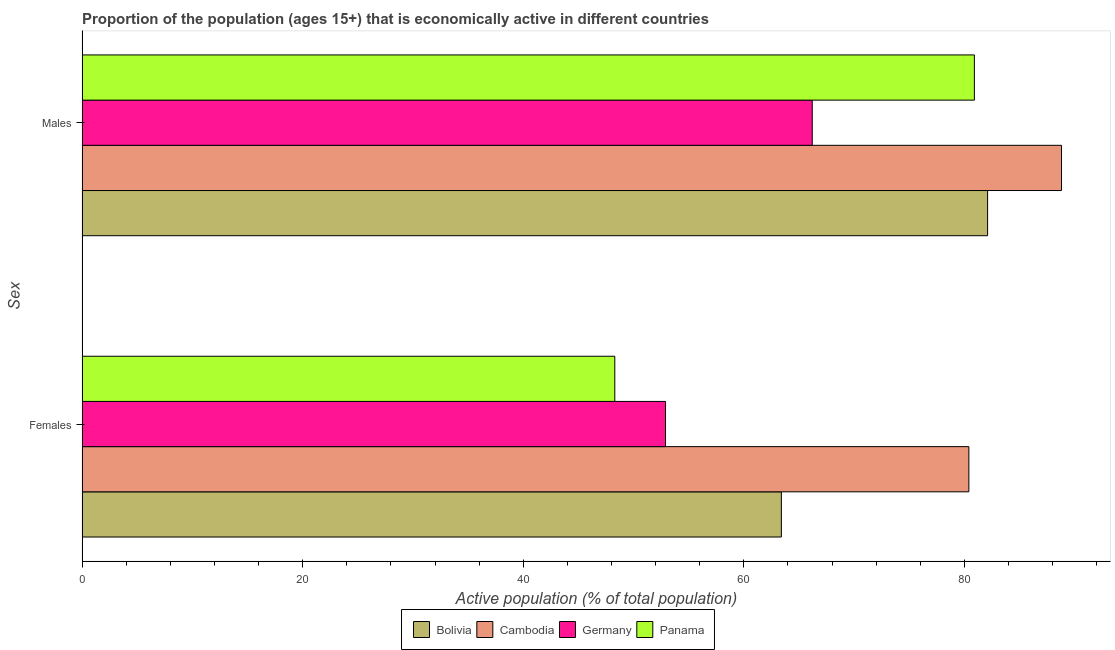How many different coloured bars are there?
Offer a very short reply. 4. How many groups of bars are there?
Your answer should be very brief. 2. How many bars are there on the 1st tick from the top?
Your answer should be compact. 4. How many bars are there on the 1st tick from the bottom?
Provide a short and direct response. 4. What is the label of the 2nd group of bars from the top?
Offer a terse response. Females. What is the percentage of economically active female population in Bolivia?
Give a very brief answer. 63.4. Across all countries, what is the maximum percentage of economically active male population?
Offer a very short reply. 88.8. Across all countries, what is the minimum percentage of economically active female population?
Provide a short and direct response. 48.3. In which country was the percentage of economically active female population maximum?
Make the answer very short. Cambodia. In which country was the percentage of economically active male population minimum?
Provide a succinct answer. Germany. What is the total percentage of economically active female population in the graph?
Your response must be concise. 245. What is the difference between the percentage of economically active male population in Cambodia and that in Panama?
Provide a succinct answer. 7.9. What is the difference between the percentage of economically active male population in Cambodia and the percentage of economically active female population in Bolivia?
Your response must be concise. 25.4. What is the average percentage of economically active female population per country?
Provide a succinct answer. 61.25. What is the difference between the percentage of economically active male population and percentage of economically active female population in Cambodia?
Give a very brief answer. 8.4. What is the ratio of the percentage of economically active female population in Panama to that in Bolivia?
Give a very brief answer. 0.76. In how many countries, is the percentage of economically active male population greater than the average percentage of economically active male population taken over all countries?
Provide a short and direct response. 3. What does the 1st bar from the top in Females represents?
Your response must be concise. Panama. What does the 1st bar from the bottom in Males represents?
Your answer should be very brief. Bolivia. How many bars are there?
Provide a short and direct response. 8. Are all the bars in the graph horizontal?
Your answer should be very brief. Yes. How many countries are there in the graph?
Your answer should be very brief. 4. Does the graph contain any zero values?
Offer a very short reply. No. Does the graph contain grids?
Your answer should be very brief. No. Where does the legend appear in the graph?
Make the answer very short. Bottom center. How many legend labels are there?
Offer a very short reply. 4. What is the title of the graph?
Your answer should be very brief. Proportion of the population (ages 15+) that is economically active in different countries. Does "Uzbekistan" appear as one of the legend labels in the graph?
Your answer should be compact. No. What is the label or title of the X-axis?
Your answer should be very brief. Active population (% of total population). What is the label or title of the Y-axis?
Make the answer very short. Sex. What is the Active population (% of total population) of Bolivia in Females?
Your response must be concise. 63.4. What is the Active population (% of total population) in Cambodia in Females?
Give a very brief answer. 80.4. What is the Active population (% of total population) of Germany in Females?
Provide a succinct answer. 52.9. What is the Active population (% of total population) in Panama in Females?
Ensure brevity in your answer.  48.3. What is the Active population (% of total population) in Bolivia in Males?
Offer a very short reply. 82.1. What is the Active population (% of total population) of Cambodia in Males?
Make the answer very short. 88.8. What is the Active population (% of total population) of Germany in Males?
Provide a short and direct response. 66.2. What is the Active population (% of total population) of Panama in Males?
Provide a short and direct response. 80.9. Across all Sex, what is the maximum Active population (% of total population) of Bolivia?
Give a very brief answer. 82.1. Across all Sex, what is the maximum Active population (% of total population) of Cambodia?
Provide a short and direct response. 88.8. Across all Sex, what is the maximum Active population (% of total population) of Germany?
Provide a short and direct response. 66.2. Across all Sex, what is the maximum Active population (% of total population) in Panama?
Your response must be concise. 80.9. Across all Sex, what is the minimum Active population (% of total population) in Bolivia?
Offer a very short reply. 63.4. Across all Sex, what is the minimum Active population (% of total population) in Cambodia?
Give a very brief answer. 80.4. Across all Sex, what is the minimum Active population (% of total population) of Germany?
Keep it short and to the point. 52.9. Across all Sex, what is the minimum Active population (% of total population) in Panama?
Your answer should be very brief. 48.3. What is the total Active population (% of total population) in Bolivia in the graph?
Provide a succinct answer. 145.5. What is the total Active population (% of total population) of Cambodia in the graph?
Make the answer very short. 169.2. What is the total Active population (% of total population) in Germany in the graph?
Your answer should be compact. 119.1. What is the total Active population (% of total population) of Panama in the graph?
Your answer should be very brief. 129.2. What is the difference between the Active population (% of total population) in Bolivia in Females and that in Males?
Offer a terse response. -18.7. What is the difference between the Active population (% of total population) of Panama in Females and that in Males?
Your response must be concise. -32.6. What is the difference between the Active population (% of total population) of Bolivia in Females and the Active population (% of total population) of Cambodia in Males?
Provide a succinct answer. -25.4. What is the difference between the Active population (% of total population) of Bolivia in Females and the Active population (% of total population) of Panama in Males?
Your answer should be very brief. -17.5. What is the difference between the Active population (% of total population) of Cambodia in Females and the Active population (% of total population) of Germany in Males?
Your response must be concise. 14.2. What is the difference between the Active population (% of total population) in Germany in Females and the Active population (% of total population) in Panama in Males?
Offer a terse response. -28. What is the average Active population (% of total population) in Bolivia per Sex?
Your answer should be compact. 72.75. What is the average Active population (% of total population) in Cambodia per Sex?
Your answer should be very brief. 84.6. What is the average Active population (% of total population) of Germany per Sex?
Your response must be concise. 59.55. What is the average Active population (% of total population) of Panama per Sex?
Provide a short and direct response. 64.6. What is the difference between the Active population (% of total population) in Cambodia and Active population (% of total population) in Panama in Females?
Provide a short and direct response. 32.1. What is the difference between the Active population (% of total population) of Germany and Active population (% of total population) of Panama in Females?
Offer a terse response. 4.6. What is the difference between the Active population (% of total population) in Bolivia and Active population (% of total population) in Cambodia in Males?
Provide a short and direct response. -6.7. What is the difference between the Active population (% of total population) of Bolivia and Active population (% of total population) of Germany in Males?
Give a very brief answer. 15.9. What is the difference between the Active population (% of total population) in Cambodia and Active population (% of total population) in Germany in Males?
Ensure brevity in your answer.  22.6. What is the difference between the Active population (% of total population) of Germany and Active population (% of total population) of Panama in Males?
Provide a succinct answer. -14.7. What is the ratio of the Active population (% of total population) in Bolivia in Females to that in Males?
Your response must be concise. 0.77. What is the ratio of the Active population (% of total population) in Cambodia in Females to that in Males?
Give a very brief answer. 0.91. What is the ratio of the Active population (% of total population) of Germany in Females to that in Males?
Offer a very short reply. 0.8. What is the ratio of the Active population (% of total population) in Panama in Females to that in Males?
Make the answer very short. 0.6. What is the difference between the highest and the second highest Active population (% of total population) of Bolivia?
Offer a very short reply. 18.7. What is the difference between the highest and the second highest Active population (% of total population) of Cambodia?
Make the answer very short. 8.4. What is the difference between the highest and the second highest Active population (% of total population) in Panama?
Your response must be concise. 32.6. What is the difference between the highest and the lowest Active population (% of total population) in Bolivia?
Your response must be concise. 18.7. What is the difference between the highest and the lowest Active population (% of total population) in Cambodia?
Your answer should be very brief. 8.4. What is the difference between the highest and the lowest Active population (% of total population) in Panama?
Your answer should be very brief. 32.6. 